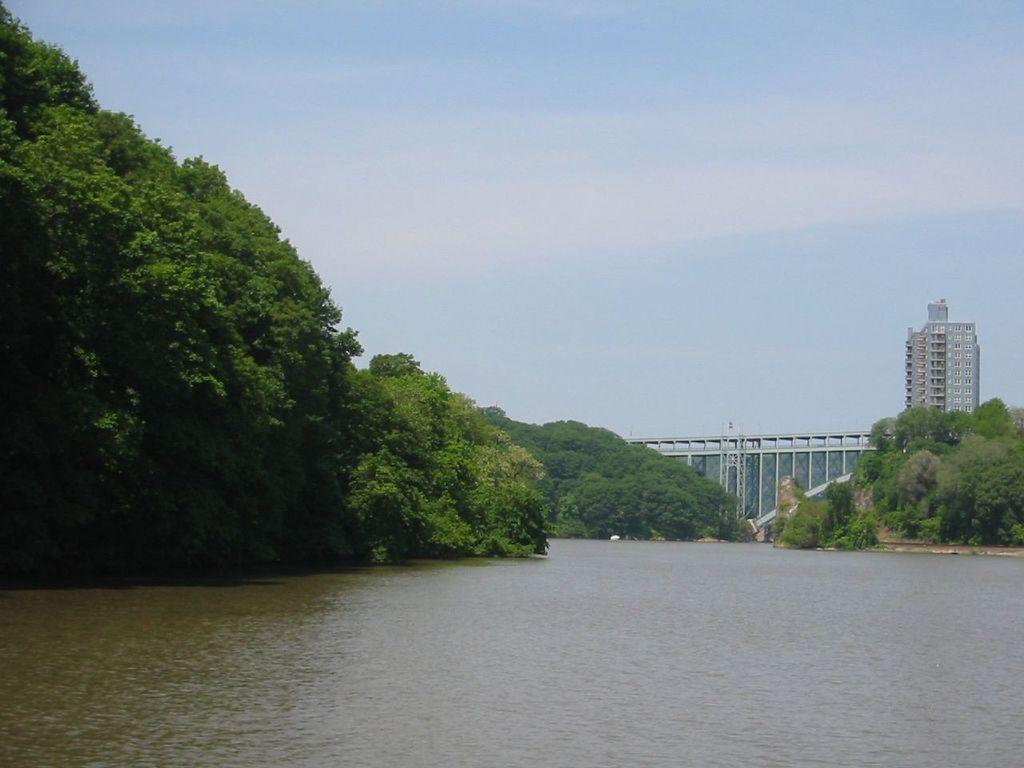What type of natural feature is present in the image? There is a river in the image. What type of vegetation can be seen in the image? There are trees in the image. What structures are visible in the background of the image? There is a bridge and a building in the background of the image. What part of the natural environment is visible in the image? The sky is visible in the background of the image. Can you see any toads jumping across the river in the image? There are no toads visible in the image, and no indication of any animals jumping across the river. 